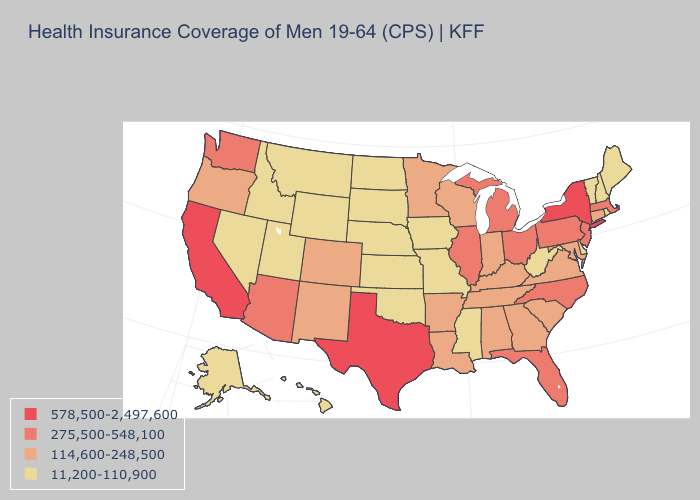What is the highest value in the USA?
Write a very short answer. 578,500-2,497,600. Name the states that have a value in the range 11,200-110,900?
Keep it brief. Alaska, Delaware, Hawaii, Idaho, Iowa, Kansas, Maine, Mississippi, Missouri, Montana, Nebraska, Nevada, New Hampshire, North Dakota, Oklahoma, Rhode Island, South Dakota, Utah, Vermont, West Virginia, Wyoming. Which states have the highest value in the USA?
Keep it brief. California, New York, Texas. Does Montana have the same value as Alabama?
Give a very brief answer. No. Does the map have missing data?
Concise answer only. No. Which states have the lowest value in the USA?
Concise answer only. Alaska, Delaware, Hawaii, Idaho, Iowa, Kansas, Maine, Mississippi, Missouri, Montana, Nebraska, Nevada, New Hampshire, North Dakota, Oklahoma, Rhode Island, South Dakota, Utah, Vermont, West Virginia, Wyoming. What is the value of South Carolina?
Keep it brief. 114,600-248,500. Which states have the lowest value in the USA?
Give a very brief answer. Alaska, Delaware, Hawaii, Idaho, Iowa, Kansas, Maine, Mississippi, Missouri, Montana, Nebraska, Nevada, New Hampshire, North Dakota, Oklahoma, Rhode Island, South Dakota, Utah, Vermont, West Virginia, Wyoming. What is the value of Maryland?
Be succinct. 114,600-248,500. Which states have the lowest value in the USA?
Keep it brief. Alaska, Delaware, Hawaii, Idaho, Iowa, Kansas, Maine, Mississippi, Missouri, Montana, Nebraska, Nevada, New Hampshire, North Dakota, Oklahoma, Rhode Island, South Dakota, Utah, Vermont, West Virginia, Wyoming. Does Arizona have the lowest value in the USA?
Short answer required. No. Among the states that border Tennessee , does Mississippi have the lowest value?
Keep it brief. Yes. Name the states that have a value in the range 114,600-248,500?
Write a very short answer. Alabama, Arkansas, Colorado, Connecticut, Georgia, Indiana, Kentucky, Louisiana, Maryland, Minnesota, New Mexico, Oregon, South Carolina, Tennessee, Virginia, Wisconsin. What is the lowest value in the USA?
Short answer required. 11,200-110,900. Does South Dakota have the lowest value in the USA?
Keep it brief. Yes. 